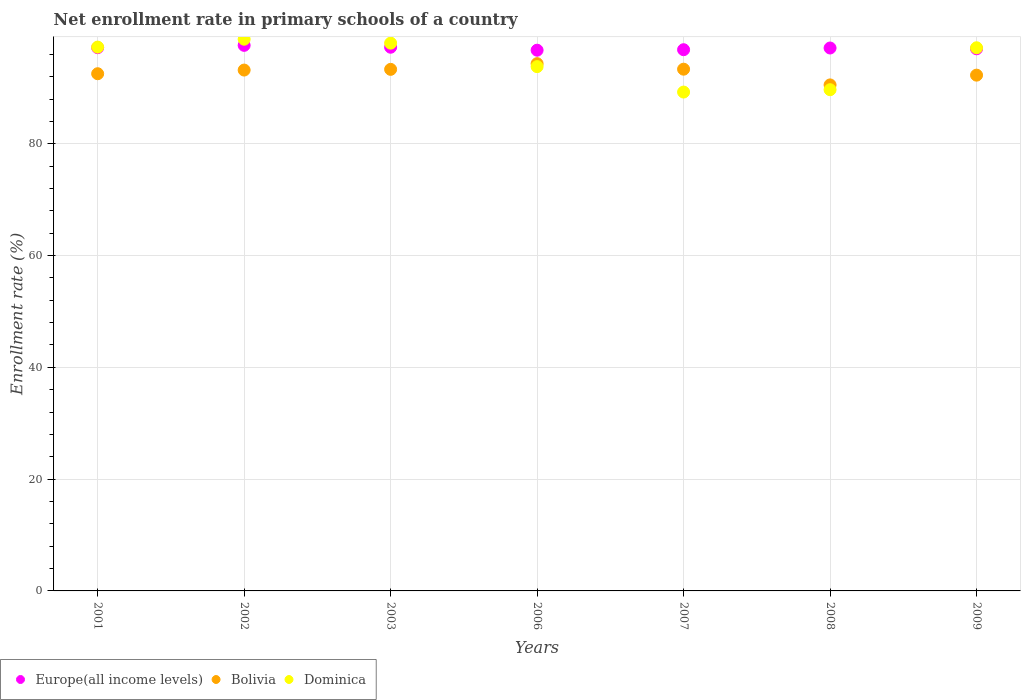Is the number of dotlines equal to the number of legend labels?
Your answer should be compact. Yes. What is the enrollment rate in primary schools in Bolivia in 2003?
Provide a short and direct response. 93.31. Across all years, what is the maximum enrollment rate in primary schools in Bolivia?
Give a very brief answer. 94.33. Across all years, what is the minimum enrollment rate in primary schools in Europe(all income levels)?
Make the answer very short. 96.74. What is the total enrollment rate in primary schools in Europe(all income levels) in the graph?
Provide a short and direct response. 679.77. What is the difference between the enrollment rate in primary schools in Dominica in 2002 and that in 2006?
Offer a terse response. 4.9. What is the difference between the enrollment rate in primary schools in Bolivia in 2009 and the enrollment rate in primary schools in Europe(all income levels) in 2008?
Make the answer very short. -4.86. What is the average enrollment rate in primary schools in Dominica per year?
Your answer should be very brief. 94.84. In the year 2002, what is the difference between the enrollment rate in primary schools in Dominica and enrollment rate in primary schools in Europe(all income levels)?
Offer a very short reply. 1.1. What is the ratio of the enrollment rate in primary schools in Dominica in 2001 to that in 2006?
Keep it short and to the point. 1.04. Is the enrollment rate in primary schools in Europe(all income levels) in 2001 less than that in 2009?
Ensure brevity in your answer.  No. Is the difference between the enrollment rate in primary schools in Dominica in 2006 and 2008 greater than the difference between the enrollment rate in primary schools in Europe(all income levels) in 2006 and 2008?
Offer a terse response. Yes. What is the difference between the highest and the second highest enrollment rate in primary schools in Bolivia?
Provide a succinct answer. 0.99. What is the difference between the highest and the lowest enrollment rate in primary schools in Bolivia?
Offer a terse response. 3.8. In how many years, is the enrollment rate in primary schools in Bolivia greater than the average enrollment rate in primary schools in Bolivia taken over all years?
Provide a succinct answer. 4. Is it the case that in every year, the sum of the enrollment rate in primary schools in Dominica and enrollment rate in primary schools in Europe(all income levels)  is greater than the enrollment rate in primary schools in Bolivia?
Offer a terse response. Yes. Is the enrollment rate in primary schools in Europe(all income levels) strictly greater than the enrollment rate in primary schools in Bolivia over the years?
Offer a terse response. Yes. How many dotlines are there?
Provide a short and direct response. 3. How many years are there in the graph?
Your answer should be compact. 7. What is the difference between two consecutive major ticks on the Y-axis?
Your answer should be compact. 20. Does the graph contain any zero values?
Give a very brief answer. No. Does the graph contain grids?
Provide a succinct answer. Yes. Where does the legend appear in the graph?
Make the answer very short. Bottom left. What is the title of the graph?
Offer a terse response. Net enrollment rate in primary schools of a country. What is the label or title of the X-axis?
Give a very brief answer. Years. What is the label or title of the Y-axis?
Offer a terse response. Enrollment rate (%). What is the Enrollment rate (%) in Europe(all income levels) in 2001?
Make the answer very short. 97.19. What is the Enrollment rate (%) in Bolivia in 2001?
Provide a short and direct response. 92.53. What is the Enrollment rate (%) of Dominica in 2001?
Your answer should be compact. 97.3. What is the Enrollment rate (%) in Europe(all income levels) in 2002?
Keep it short and to the point. 97.61. What is the Enrollment rate (%) of Bolivia in 2002?
Your answer should be compact. 93.19. What is the Enrollment rate (%) of Dominica in 2002?
Offer a terse response. 98.71. What is the Enrollment rate (%) in Europe(all income levels) in 2003?
Ensure brevity in your answer.  97.27. What is the Enrollment rate (%) of Bolivia in 2003?
Your response must be concise. 93.31. What is the Enrollment rate (%) in Dominica in 2003?
Your answer should be compact. 98. What is the Enrollment rate (%) of Europe(all income levels) in 2006?
Provide a short and direct response. 96.74. What is the Enrollment rate (%) in Bolivia in 2006?
Provide a short and direct response. 94.33. What is the Enrollment rate (%) in Dominica in 2006?
Your answer should be compact. 93.8. What is the Enrollment rate (%) of Europe(all income levels) in 2007?
Your answer should be compact. 96.83. What is the Enrollment rate (%) in Bolivia in 2007?
Provide a short and direct response. 93.34. What is the Enrollment rate (%) in Dominica in 2007?
Make the answer very short. 89.25. What is the Enrollment rate (%) of Europe(all income levels) in 2008?
Keep it short and to the point. 97.13. What is the Enrollment rate (%) of Bolivia in 2008?
Provide a short and direct response. 90.53. What is the Enrollment rate (%) of Dominica in 2008?
Provide a short and direct response. 89.67. What is the Enrollment rate (%) of Europe(all income levels) in 2009?
Make the answer very short. 96.99. What is the Enrollment rate (%) in Bolivia in 2009?
Offer a terse response. 92.28. What is the Enrollment rate (%) in Dominica in 2009?
Give a very brief answer. 97.18. Across all years, what is the maximum Enrollment rate (%) in Europe(all income levels)?
Your response must be concise. 97.61. Across all years, what is the maximum Enrollment rate (%) of Bolivia?
Make the answer very short. 94.33. Across all years, what is the maximum Enrollment rate (%) of Dominica?
Your answer should be very brief. 98.71. Across all years, what is the minimum Enrollment rate (%) of Europe(all income levels)?
Offer a terse response. 96.74. Across all years, what is the minimum Enrollment rate (%) in Bolivia?
Offer a terse response. 90.53. Across all years, what is the minimum Enrollment rate (%) in Dominica?
Your answer should be very brief. 89.25. What is the total Enrollment rate (%) of Europe(all income levels) in the graph?
Provide a short and direct response. 679.77. What is the total Enrollment rate (%) in Bolivia in the graph?
Provide a succinct answer. 649.52. What is the total Enrollment rate (%) in Dominica in the graph?
Your answer should be compact. 663.91. What is the difference between the Enrollment rate (%) of Europe(all income levels) in 2001 and that in 2002?
Your answer should be compact. -0.42. What is the difference between the Enrollment rate (%) in Bolivia in 2001 and that in 2002?
Ensure brevity in your answer.  -0.66. What is the difference between the Enrollment rate (%) in Dominica in 2001 and that in 2002?
Your response must be concise. -1.41. What is the difference between the Enrollment rate (%) of Europe(all income levels) in 2001 and that in 2003?
Provide a short and direct response. -0.08. What is the difference between the Enrollment rate (%) of Bolivia in 2001 and that in 2003?
Offer a terse response. -0.78. What is the difference between the Enrollment rate (%) of Dominica in 2001 and that in 2003?
Your response must be concise. -0.71. What is the difference between the Enrollment rate (%) in Europe(all income levels) in 2001 and that in 2006?
Give a very brief answer. 0.45. What is the difference between the Enrollment rate (%) in Bolivia in 2001 and that in 2006?
Provide a short and direct response. -1.8. What is the difference between the Enrollment rate (%) in Dominica in 2001 and that in 2006?
Make the answer very short. 3.49. What is the difference between the Enrollment rate (%) in Europe(all income levels) in 2001 and that in 2007?
Provide a succinct answer. 0.36. What is the difference between the Enrollment rate (%) of Bolivia in 2001 and that in 2007?
Keep it short and to the point. -0.81. What is the difference between the Enrollment rate (%) in Dominica in 2001 and that in 2007?
Your answer should be compact. 8.04. What is the difference between the Enrollment rate (%) of Europe(all income levels) in 2001 and that in 2008?
Provide a short and direct response. 0.05. What is the difference between the Enrollment rate (%) of Bolivia in 2001 and that in 2008?
Give a very brief answer. 2. What is the difference between the Enrollment rate (%) in Dominica in 2001 and that in 2008?
Offer a terse response. 7.62. What is the difference between the Enrollment rate (%) of Europe(all income levels) in 2001 and that in 2009?
Offer a very short reply. 0.2. What is the difference between the Enrollment rate (%) in Bolivia in 2001 and that in 2009?
Keep it short and to the point. 0.26. What is the difference between the Enrollment rate (%) of Dominica in 2001 and that in 2009?
Ensure brevity in your answer.  0.12. What is the difference between the Enrollment rate (%) in Europe(all income levels) in 2002 and that in 2003?
Keep it short and to the point. 0.34. What is the difference between the Enrollment rate (%) of Bolivia in 2002 and that in 2003?
Provide a short and direct response. -0.13. What is the difference between the Enrollment rate (%) in Dominica in 2002 and that in 2003?
Your response must be concise. 0.7. What is the difference between the Enrollment rate (%) in Europe(all income levels) in 2002 and that in 2006?
Provide a succinct answer. 0.87. What is the difference between the Enrollment rate (%) of Bolivia in 2002 and that in 2006?
Provide a succinct answer. -1.14. What is the difference between the Enrollment rate (%) of Dominica in 2002 and that in 2006?
Your answer should be compact. 4.9. What is the difference between the Enrollment rate (%) of Europe(all income levels) in 2002 and that in 2007?
Your response must be concise. 0.78. What is the difference between the Enrollment rate (%) of Bolivia in 2002 and that in 2007?
Your answer should be compact. -0.16. What is the difference between the Enrollment rate (%) of Dominica in 2002 and that in 2007?
Your response must be concise. 9.46. What is the difference between the Enrollment rate (%) of Europe(all income levels) in 2002 and that in 2008?
Offer a terse response. 0.47. What is the difference between the Enrollment rate (%) in Bolivia in 2002 and that in 2008?
Offer a very short reply. 2.66. What is the difference between the Enrollment rate (%) in Dominica in 2002 and that in 2008?
Your answer should be very brief. 9.03. What is the difference between the Enrollment rate (%) in Europe(all income levels) in 2002 and that in 2009?
Offer a very short reply. 0.61. What is the difference between the Enrollment rate (%) in Bolivia in 2002 and that in 2009?
Make the answer very short. 0.91. What is the difference between the Enrollment rate (%) in Dominica in 2002 and that in 2009?
Provide a succinct answer. 1.53. What is the difference between the Enrollment rate (%) of Europe(all income levels) in 2003 and that in 2006?
Your answer should be very brief. 0.53. What is the difference between the Enrollment rate (%) in Bolivia in 2003 and that in 2006?
Your answer should be very brief. -1.02. What is the difference between the Enrollment rate (%) in Dominica in 2003 and that in 2006?
Provide a succinct answer. 4.2. What is the difference between the Enrollment rate (%) of Europe(all income levels) in 2003 and that in 2007?
Offer a very short reply. 0.44. What is the difference between the Enrollment rate (%) of Bolivia in 2003 and that in 2007?
Your response must be concise. -0.03. What is the difference between the Enrollment rate (%) in Dominica in 2003 and that in 2007?
Your answer should be very brief. 8.75. What is the difference between the Enrollment rate (%) of Europe(all income levels) in 2003 and that in 2008?
Provide a succinct answer. 0.14. What is the difference between the Enrollment rate (%) in Bolivia in 2003 and that in 2008?
Offer a terse response. 2.78. What is the difference between the Enrollment rate (%) in Dominica in 2003 and that in 2008?
Provide a short and direct response. 8.33. What is the difference between the Enrollment rate (%) in Europe(all income levels) in 2003 and that in 2009?
Offer a terse response. 0.28. What is the difference between the Enrollment rate (%) in Bolivia in 2003 and that in 2009?
Keep it short and to the point. 1.04. What is the difference between the Enrollment rate (%) in Dominica in 2003 and that in 2009?
Offer a terse response. 0.83. What is the difference between the Enrollment rate (%) in Europe(all income levels) in 2006 and that in 2007?
Offer a terse response. -0.09. What is the difference between the Enrollment rate (%) of Dominica in 2006 and that in 2007?
Provide a succinct answer. 4.55. What is the difference between the Enrollment rate (%) of Europe(all income levels) in 2006 and that in 2008?
Offer a terse response. -0.39. What is the difference between the Enrollment rate (%) in Bolivia in 2006 and that in 2008?
Offer a terse response. 3.8. What is the difference between the Enrollment rate (%) in Dominica in 2006 and that in 2008?
Provide a succinct answer. 4.13. What is the difference between the Enrollment rate (%) of Europe(all income levels) in 2006 and that in 2009?
Your answer should be compact. -0.25. What is the difference between the Enrollment rate (%) in Bolivia in 2006 and that in 2009?
Offer a very short reply. 2.06. What is the difference between the Enrollment rate (%) in Dominica in 2006 and that in 2009?
Your response must be concise. -3.37. What is the difference between the Enrollment rate (%) of Europe(all income levels) in 2007 and that in 2008?
Make the answer very short. -0.3. What is the difference between the Enrollment rate (%) of Bolivia in 2007 and that in 2008?
Make the answer very short. 2.81. What is the difference between the Enrollment rate (%) of Dominica in 2007 and that in 2008?
Your answer should be compact. -0.42. What is the difference between the Enrollment rate (%) of Europe(all income levels) in 2007 and that in 2009?
Keep it short and to the point. -0.16. What is the difference between the Enrollment rate (%) of Bolivia in 2007 and that in 2009?
Your answer should be very brief. 1.07. What is the difference between the Enrollment rate (%) in Dominica in 2007 and that in 2009?
Ensure brevity in your answer.  -7.92. What is the difference between the Enrollment rate (%) in Europe(all income levels) in 2008 and that in 2009?
Offer a very short reply. 0.14. What is the difference between the Enrollment rate (%) of Bolivia in 2008 and that in 2009?
Ensure brevity in your answer.  -1.75. What is the difference between the Enrollment rate (%) of Dominica in 2008 and that in 2009?
Your answer should be compact. -7.5. What is the difference between the Enrollment rate (%) in Europe(all income levels) in 2001 and the Enrollment rate (%) in Bolivia in 2002?
Offer a terse response. 4. What is the difference between the Enrollment rate (%) in Europe(all income levels) in 2001 and the Enrollment rate (%) in Dominica in 2002?
Keep it short and to the point. -1.52. What is the difference between the Enrollment rate (%) of Bolivia in 2001 and the Enrollment rate (%) of Dominica in 2002?
Your answer should be very brief. -6.17. What is the difference between the Enrollment rate (%) of Europe(all income levels) in 2001 and the Enrollment rate (%) of Bolivia in 2003?
Keep it short and to the point. 3.88. What is the difference between the Enrollment rate (%) in Europe(all income levels) in 2001 and the Enrollment rate (%) in Dominica in 2003?
Give a very brief answer. -0.81. What is the difference between the Enrollment rate (%) of Bolivia in 2001 and the Enrollment rate (%) of Dominica in 2003?
Your answer should be very brief. -5.47. What is the difference between the Enrollment rate (%) in Europe(all income levels) in 2001 and the Enrollment rate (%) in Bolivia in 2006?
Give a very brief answer. 2.86. What is the difference between the Enrollment rate (%) in Europe(all income levels) in 2001 and the Enrollment rate (%) in Dominica in 2006?
Offer a very short reply. 3.39. What is the difference between the Enrollment rate (%) of Bolivia in 2001 and the Enrollment rate (%) of Dominica in 2006?
Keep it short and to the point. -1.27. What is the difference between the Enrollment rate (%) in Europe(all income levels) in 2001 and the Enrollment rate (%) in Bolivia in 2007?
Your response must be concise. 3.84. What is the difference between the Enrollment rate (%) in Europe(all income levels) in 2001 and the Enrollment rate (%) in Dominica in 2007?
Ensure brevity in your answer.  7.94. What is the difference between the Enrollment rate (%) of Bolivia in 2001 and the Enrollment rate (%) of Dominica in 2007?
Provide a short and direct response. 3.28. What is the difference between the Enrollment rate (%) in Europe(all income levels) in 2001 and the Enrollment rate (%) in Bolivia in 2008?
Give a very brief answer. 6.66. What is the difference between the Enrollment rate (%) of Europe(all income levels) in 2001 and the Enrollment rate (%) of Dominica in 2008?
Offer a terse response. 7.51. What is the difference between the Enrollment rate (%) in Bolivia in 2001 and the Enrollment rate (%) in Dominica in 2008?
Offer a terse response. 2.86. What is the difference between the Enrollment rate (%) of Europe(all income levels) in 2001 and the Enrollment rate (%) of Bolivia in 2009?
Provide a succinct answer. 4.91. What is the difference between the Enrollment rate (%) in Europe(all income levels) in 2001 and the Enrollment rate (%) in Dominica in 2009?
Provide a succinct answer. 0.01. What is the difference between the Enrollment rate (%) in Bolivia in 2001 and the Enrollment rate (%) in Dominica in 2009?
Offer a very short reply. -4.64. What is the difference between the Enrollment rate (%) in Europe(all income levels) in 2002 and the Enrollment rate (%) in Bolivia in 2003?
Your response must be concise. 4.29. What is the difference between the Enrollment rate (%) of Europe(all income levels) in 2002 and the Enrollment rate (%) of Dominica in 2003?
Your answer should be very brief. -0.39. What is the difference between the Enrollment rate (%) of Bolivia in 2002 and the Enrollment rate (%) of Dominica in 2003?
Your answer should be very brief. -4.82. What is the difference between the Enrollment rate (%) in Europe(all income levels) in 2002 and the Enrollment rate (%) in Bolivia in 2006?
Keep it short and to the point. 3.28. What is the difference between the Enrollment rate (%) in Europe(all income levels) in 2002 and the Enrollment rate (%) in Dominica in 2006?
Offer a very short reply. 3.8. What is the difference between the Enrollment rate (%) in Bolivia in 2002 and the Enrollment rate (%) in Dominica in 2006?
Ensure brevity in your answer.  -0.62. What is the difference between the Enrollment rate (%) of Europe(all income levels) in 2002 and the Enrollment rate (%) of Bolivia in 2007?
Offer a terse response. 4.26. What is the difference between the Enrollment rate (%) of Europe(all income levels) in 2002 and the Enrollment rate (%) of Dominica in 2007?
Ensure brevity in your answer.  8.36. What is the difference between the Enrollment rate (%) in Bolivia in 2002 and the Enrollment rate (%) in Dominica in 2007?
Provide a short and direct response. 3.94. What is the difference between the Enrollment rate (%) of Europe(all income levels) in 2002 and the Enrollment rate (%) of Bolivia in 2008?
Your response must be concise. 7.08. What is the difference between the Enrollment rate (%) in Europe(all income levels) in 2002 and the Enrollment rate (%) in Dominica in 2008?
Offer a very short reply. 7.93. What is the difference between the Enrollment rate (%) in Bolivia in 2002 and the Enrollment rate (%) in Dominica in 2008?
Ensure brevity in your answer.  3.51. What is the difference between the Enrollment rate (%) in Europe(all income levels) in 2002 and the Enrollment rate (%) in Bolivia in 2009?
Your answer should be compact. 5.33. What is the difference between the Enrollment rate (%) of Europe(all income levels) in 2002 and the Enrollment rate (%) of Dominica in 2009?
Make the answer very short. 0.43. What is the difference between the Enrollment rate (%) in Bolivia in 2002 and the Enrollment rate (%) in Dominica in 2009?
Keep it short and to the point. -3.99. What is the difference between the Enrollment rate (%) in Europe(all income levels) in 2003 and the Enrollment rate (%) in Bolivia in 2006?
Your answer should be very brief. 2.94. What is the difference between the Enrollment rate (%) of Europe(all income levels) in 2003 and the Enrollment rate (%) of Dominica in 2006?
Make the answer very short. 3.47. What is the difference between the Enrollment rate (%) in Bolivia in 2003 and the Enrollment rate (%) in Dominica in 2006?
Keep it short and to the point. -0.49. What is the difference between the Enrollment rate (%) in Europe(all income levels) in 2003 and the Enrollment rate (%) in Bolivia in 2007?
Give a very brief answer. 3.93. What is the difference between the Enrollment rate (%) of Europe(all income levels) in 2003 and the Enrollment rate (%) of Dominica in 2007?
Keep it short and to the point. 8.02. What is the difference between the Enrollment rate (%) in Bolivia in 2003 and the Enrollment rate (%) in Dominica in 2007?
Provide a short and direct response. 4.06. What is the difference between the Enrollment rate (%) in Europe(all income levels) in 2003 and the Enrollment rate (%) in Bolivia in 2008?
Offer a very short reply. 6.74. What is the difference between the Enrollment rate (%) of Europe(all income levels) in 2003 and the Enrollment rate (%) of Dominica in 2008?
Offer a very short reply. 7.6. What is the difference between the Enrollment rate (%) in Bolivia in 2003 and the Enrollment rate (%) in Dominica in 2008?
Ensure brevity in your answer.  3.64. What is the difference between the Enrollment rate (%) in Europe(all income levels) in 2003 and the Enrollment rate (%) in Bolivia in 2009?
Your response must be concise. 4.99. What is the difference between the Enrollment rate (%) of Europe(all income levels) in 2003 and the Enrollment rate (%) of Dominica in 2009?
Make the answer very short. 0.1. What is the difference between the Enrollment rate (%) in Bolivia in 2003 and the Enrollment rate (%) in Dominica in 2009?
Your answer should be compact. -3.86. What is the difference between the Enrollment rate (%) of Europe(all income levels) in 2006 and the Enrollment rate (%) of Bolivia in 2007?
Keep it short and to the point. 3.4. What is the difference between the Enrollment rate (%) of Europe(all income levels) in 2006 and the Enrollment rate (%) of Dominica in 2007?
Keep it short and to the point. 7.49. What is the difference between the Enrollment rate (%) in Bolivia in 2006 and the Enrollment rate (%) in Dominica in 2007?
Your answer should be very brief. 5.08. What is the difference between the Enrollment rate (%) in Europe(all income levels) in 2006 and the Enrollment rate (%) in Bolivia in 2008?
Keep it short and to the point. 6.21. What is the difference between the Enrollment rate (%) in Europe(all income levels) in 2006 and the Enrollment rate (%) in Dominica in 2008?
Make the answer very short. 7.07. What is the difference between the Enrollment rate (%) of Bolivia in 2006 and the Enrollment rate (%) of Dominica in 2008?
Your answer should be very brief. 4.66. What is the difference between the Enrollment rate (%) in Europe(all income levels) in 2006 and the Enrollment rate (%) in Bolivia in 2009?
Offer a very short reply. 4.46. What is the difference between the Enrollment rate (%) in Europe(all income levels) in 2006 and the Enrollment rate (%) in Dominica in 2009?
Offer a terse response. -0.43. What is the difference between the Enrollment rate (%) in Bolivia in 2006 and the Enrollment rate (%) in Dominica in 2009?
Provide a succinct answer. -2.84. What is the difference between the Enrollment rate (%) in Europe(all income levels) in 2007 and the Enrollment rate (%) in Bolivia in 2008?
Offer a very short reply. 6.3. What is the difference between the Enrollment rate (%) in Europe(all income levels) in 2007 and the Enrollment rate (%) in Dominica in 2008?
Ensure brevity in your answer.  7.16. What is the difference between the Enrollment rate (%) in Bolivia in 2007 and the Enrollment rate (%) in Dominica in 2008?
Offer a very short reply. 3.67. What is the difference between the Enrollment rate (%) of Europe(all income levels) in 2007 and the Enrollment rate (%) of Bolivia in 2009?
Ensure brevity in your answer.  4.55. What is the difference between the Enrollment rate (%) in Europe(all income levels) in 2007 and the Enrollment rate (%) in Dominica in 2009?
Provide a succinct answer. -0.34. What is the difference between the Enrollment rate (%) of Bolivia in 2007 and the Enrollment rate (%) of Dominica in 2009?
Ensure brevity in your answer.  -3.83. What is the difference between the Enrollment rate (%) in Europe(all income levels) in 2008 and the Enrollment rate (%) in Bolivia in 2009?
Provide a succinct answer. 4.86. What is the difference between the Enrollment rate (%) in Europe(all income levels) in 2008 and the Enrollment rate (%) in Dominica in 2009?
Provide a short and direct response. -0.04. What is the difference between the Enrollment rate (%) in Bolivia in 2008 and the Enrollment rate (%) in Dominica in 2009?
Provide a short and direct response. -6.64. What is the average Enrollment rate (%) in Europe(all income levels) per year?
Your answer should be compact. 97.11. What is the average Enrollment rate (%) of Bolivia per year?
Your answer should be compact. 92.79. What is the average Enrollment rate (%) in Dominica per year?
Offer a very short reply. 94.84. In the year 2001, what is the difference between the Enrollment rate (%) in Europe(all income levels) and Enrollment rate (%) in Bolivia?
Keep it short and to the point. 4.66. In the year 2001, what is the difference between the Enrollment rate (%) in Europe(all income levels) and Enrollment rate (%) in Dominica?
Keep it short and to the point. -0.11. In the year 2001, what is the difference between the Enrollment rate (%) of Bolivia and Enrollment rate (%) of Dominica?
Your response must be concise. -4.76. In the year 2002, what is the difference between the Enrollment rate (%) in Europe(all income levels) and Enrollment rate (%) in Bolivia?
Offer a very short reply. 4.42. In the year 2002, what is the difference between the Enrollment rate (%) of Europe(all income levels) and Enrollment rate (%) of Dominica?
Your response must be concise. -1.1. In the year 2002, what is the difference between the Enrollment rate (%) of Bolivia and Enrollment rate (%) of Dominica?
Provide a succinct answer. -5.52. In the year 2003, what is the difference between the Enrollment rate (%) of Europe(all income levels) and Enrollment rate (%) of Bolivia?
Give a very brief answer. 3.96. In the year 2003, what is the difference between the Enrollment rate (%) of Europe(all income levels) and Enrollment rate (%) of Dominica?
Ensure brevity in your answer.  -0.73. In the year 2003, what is the difference between the Enrollment rate (%) in Bolivia and Enrollment rate (%) in Dominica?
Keep it short and to the point. -4.69. In the year 2006, what is the difference between the Enrollment rate (%) of Europe(all income levels) and Enrollment rate (%) of Bolivia?
Give a very brief answer. 2.41. In the year 2006, what is the difference between the Enrollment rate (%) in Europe(all income levels) and Enrollment rate (%) in Dominica?
Offer a terse response. 2.94. In the year 2006, what is the difference between the Enrollment rate (%) in Bolivia and Enrollment rate (%) in Dominica?
Your answer should be very brief. 0.53. In the year 2007, what is the difference between the Enrollment rate (%) in Europe(all income levels) and Enrollment rate (%) in Bolivia?
Your answer should be compact. 3.49. In the year 2007, what is the difference between the Enrollment rate (%) of Europe(all income levels) and Enrollment rate (%) of Dominica?
Provide a short and direct response. 7.58. In the year 2007, what is the difference between the Enrollment rate (%) in Bolivia and Enrollment rate (%) in Dominica?
Give a very brief answer. 4.09. In the year 2008, what is the difference between the Enrollment rate (%) in Europe(all income levels) and Enrollment rate (%) in Bolivia?
Your answer should be compact. 6.6. In the year 2008, what is the difference between the Enrollment rate (%) of Europe(all income levels) and Enrollment rate (%) of Dominica?
Your answer should be very brief. 7.46. In the year 2008, what is the difference between the Enrollment rate (%) of Bolivia and Enrollment rate (%) of Dominica?
Offer a terse response. 0.86. In the year 2009, what is the difference between the Enrollment rate (%) of Europe(all income levels) and Enrollment rate (%) of Bolivia?
Make the answer very short. 4.72. In the year 2009, what is the difference between the Enrollment rate (%) in Europe(all income levels) and Enrollment rate (%) in Dominica?
Make the answer very short. -0.18. In the year 2009, what is the difference between the Enrollment rate (%) in Bolivia and Enrollment rate (%) in Dominica?
Ensure brevity in your answer.  -4.9. What is the ratio of the Enrollment rate (%) in Dominica in 2001 to that in 2002?
Offer a terse response. 0.99. What is the ratio of the Enrollment rate (%) of Bolivia in 2001 to that in 2003?
Provide a succinct answer. 0.99. What is the ratio of the Enrollment rate (%) of Bolivia in 2001 to that in 2006?
Provide a succinct answer. 0.98. What is the ratio of the Enrollment rate (%) in Dominica in 2001 to that in 2006?
Keep it short and to the point. 1.04. What is the ratio of the Enrollment rate (%) of Europe(all income levels) in 2001 to that in 2007?
Offer a terse response. 1. What is the ratio of the Enrollment rate (%) of Bolivia in 2001 to that in 2007?
Your response must be concise. 0.99. What is the ratio of the Enrollment rate (%) of Dominica in 2001 to that in 2007?
Give a very brief answer. 1.09. What is the ratio of the Enrollment rate (%) in Europe(all income levels) in 2001 to that in 2008?
Keep it short and to the point. 1. What is the ratio of the Enrollment rate (%) of Bolivia in 2001 to that in 2008?
Provide a succinct answer. 1.02. What is the ratio of the Enrollment rate (%) of Dominica in 2001 to that in 2008?
Provide a succinct answer. 1.08. What is the ratio of the Enrollment rate (%) in Europe(all income levels) in 2001 to that in 2009?
Offer a very short reply. 1. What is the ratio of the Enrollment rate (%) in Bolivia in 2001 to that in 2009?
Your response must be concise. 1. What is the ratio of the Enrollment rate (%) of Dominica in 2001 to that in 2009?
Offer a very short reply. 1. What is the ratio of the Enrollment rate (%) of Dominica in 2002 to that in 2003?
Make the answer very short. 1.01. What is the ratio of the Enrollment rate (%) in Europe(all income levels) in 2002 to that in 2006?
Keep it short and to the point. 1.01. What is the ratio of the Enrollment rate (%) of Bolivia in 2002 to that in 2006?
Give a very brief answer. 0.99. What is the ratio of the Enrollment rate (%) in Dominica in 2002 to that in 2006?
Provide a short and direct response. 1.05. What is the ratio of the Enrollment rate (%) in Dominica in 2002 to that in 2007?
Make the answer very short. 1.11. What is the ratio of the Enrollment rate (%) in Europe(all income levels) in 2002 to that in 2008?
Offer a terse response. 1. What is the ratio of the Enrollment rate (%) of Bolivia in 2002 to that in 2008?
Your response must be concise. 1.03. What is the ratio of the Enrollment rate (%) in Dominica in 2002 to that in 2008?
Your response must be concise. 1.1. What is the ratio of the Enrollment rate (%) of Bolivia in 2002 to that in 2009?
Provide a succinct answer. 1.01. What is the ratio of the Enrollment rate (%) of Dominica in 2002 to that in 2009?
Offer a terse response. 1.02. What is the ratio of the Enrollment rate (%) in Bolivia in 2003 to that in 2006?
Your response must be concise. 0.99. What is the ratio of the Enrollment rate (%) in Dominica in 2003 to that in 2006?
Your answer should be compact. 1.04. What is the ratio of the Enrollment rate (%) in Europe(all income levels) in 2003 to that in 2007?
Give a very brief answer. 1. What is the ratio of the Enrollment rate (%) in Dominica in 2003 to that in 2007?
Your response must be concise. 1.1. What is the ratio of the Enrollment rate (%) in Bolivia in 2003 to that in 2008?
Provide a short and direct response. 1.03. What is the ratio of the Enrollment rate (%) in Dominica in 2003 to that in 2008?
Your answer should be compact. 1.09. What is the ratio of the Enrollment rate (%) in Bolivia in 2003 to that in 2009?
Your answer should be compact. 1.01. What is the ratio of the Enrollment rate (%) in Dominica in 2003 to that in 2009?
Make the answer very short. 1.01. What is the ratio of the Enrollment rate (%) in Europe(all income levels) in 2006 to that in 2007?
Offer a terse response. 1. What is the ratio of the Enrollment rate (%) of Bolivia in 2006 to that in 2007?
Give a very brief answer. 1.01. What is the ratio of the Enrollment rate (%) of Dominica in 2006 to that in 2007?
Your answer should be very brief. 1.05. What is the ratio of the Enrollment rate (%) in Europe(all income levels) in 2006 to that in 2008?
Make the answer very short. 1. What is the ratio of the Enrollment rate (%) in Bolivia in 2006 to that in 2008?
Ensure brevity in your answer.  1.04. What is the ratio of the Enrollment rate (%) in Dominica in 2006 to that in 2008?
Make the answer very short. 1.05. What is the ratio of the Enrollment rate (%) of Europe(all income levels) in 2006 to that in 2009?
Your answer should be compact. 1. What is the ratio of the Enrollment rate (%) in Bolivia in 2006 to that in 2009?
Keep it short and to the point. 1.02. What is the ratio of the Enrollment rate (%) in Dominica in 2006 to that in 2009?
Your response must be concise. 0.97. What is the ratio of the Enrollment rate (%) of Europe(all income levels) in 2007 to that in 2008?
Make the answer very short. 1. What is the ratio of the Enrollment rate (%) in Bolivia in 2007 to that in 2008?
Your answer should be compact. 1.03. What is the ratio of the Enrollment rate (%) in Dominica in 2007 to that in 2008?
Ensure brevity in your answer.  1. What is the ratio of the Enrollment rate (%) of Bolivia in 2007 to that in 2009?
Offer a terse response. 1.01. What is the ratio of the Enrollment rate (%) of Dominica in 2007 to that in 2009?
Your answer should be very brief. 0.92. What is the ratio of the Enrollment rate (%) of Bolivia in 2008 to that in 2009?
Ensure brevity in your answer.  0.98. What is the ratio of the Enrollment rate (%) of Dominica in 2008 to that in 2009?
Offer a terse response. 0.92. What is the difference between the highest and the second highest Enrollment rate (%) of Europe(all income levels)?
Provide a succinct answer. 0.34. What is the difference between the highest and the second highest Enrollment rate (%) of Bolivia?
Your answer should be very brief. 0.99. What is the difference between the highest and the second highest Enrollment rate (%) of Dominica?
Your answer should be compact. 0.7. What is the difference between the highest and the lowest Enrollment rate (%) of Europe(all income levels)?
Give a very brief answer. 0.87. What is the difference between the highest and the lowest Enrollment rate (%) of Bolivia?
Provide a short and direct response. 3.8. What is the difference between the highest and the lowest Enrollment rate (%) in Dominica?
Provide a short and direct response. 9.46. 